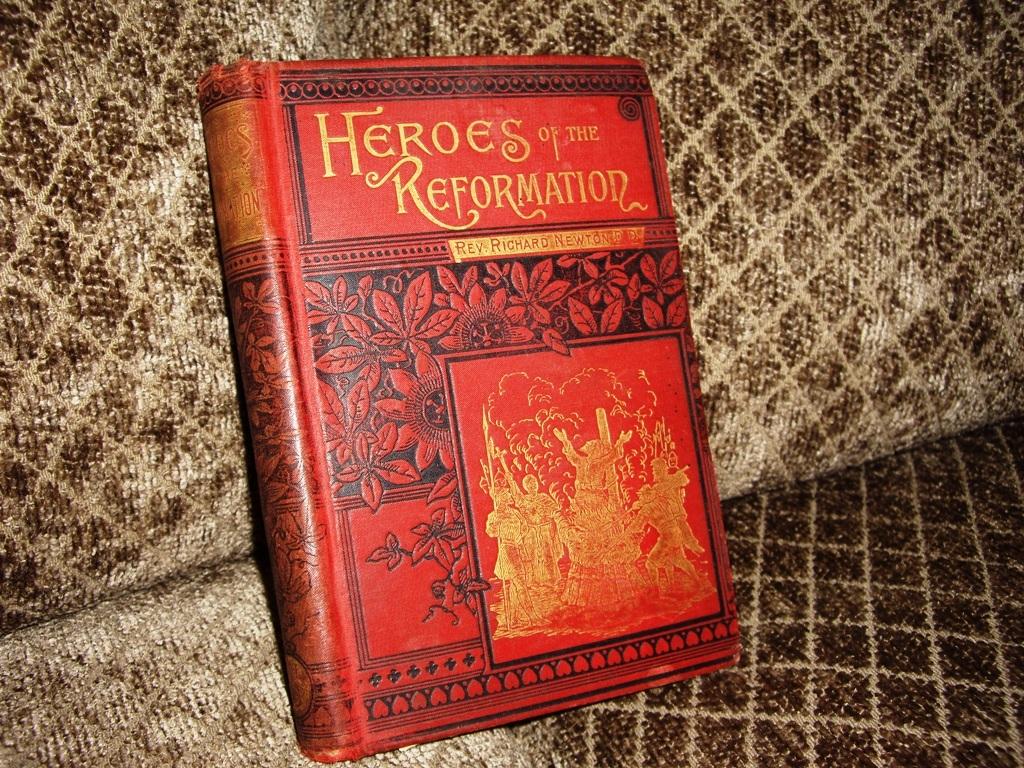What's the title of the book?
Keep it short and to the point. Heroes of the reformation. Who wrote the book?
Your answer should be compact. Unanswerable. 